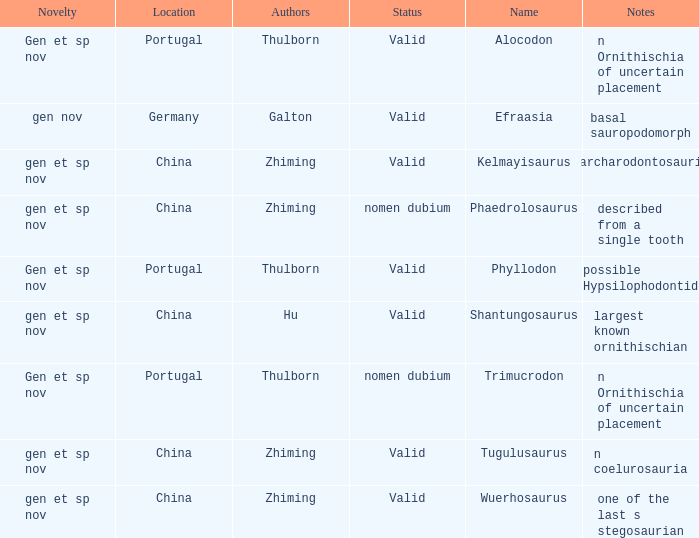What is the Name of the dinosaur, whose notes are, "n ornithischia of uncertain placement"? Alocodon, Trimucrodon. 